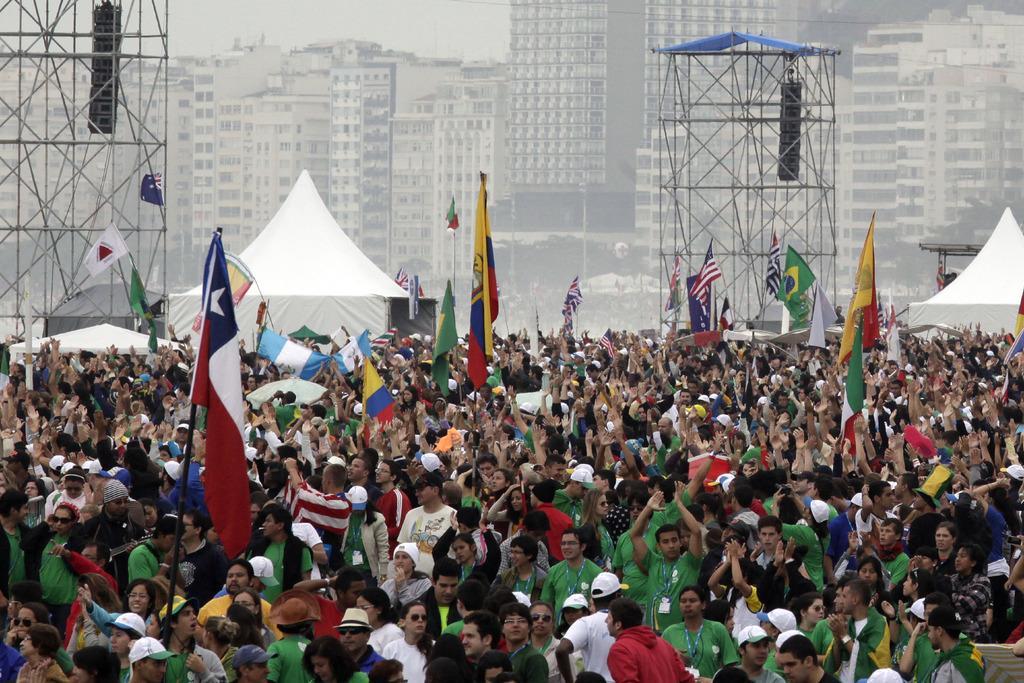In one or two sentences, can you explain what this image depicts? At the bottom we can see few persons are standing and among them few are holding flag poles in their hands. In the background there are poles, tents, trees, buildings and sky. 